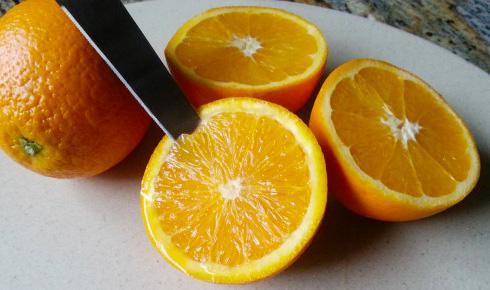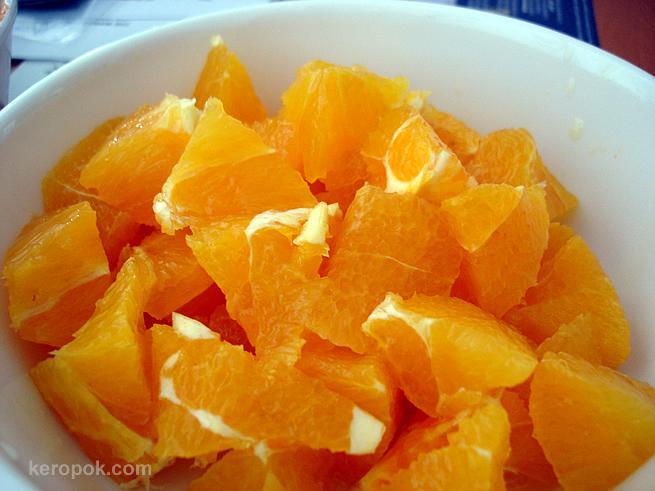The first image is the image on the left, the second image is the image on the right. Given the left and right images, does the statement "In the left image, there is only 1 piece of fruit cut into halves." hold true? Answer yes or no. No. 